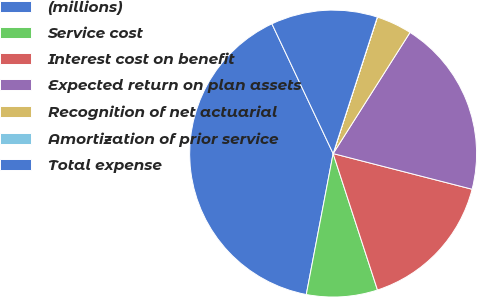<chart> <loc_0><loc_0><loc_500><loc_500><pie_chart><fcel>(millions)<fcel>Service cost<fcel>Interest cost on benefit<fcel>Expected return on plan assets<fcel>Recognition of net actuarial<fcel>Amortization of prior service<fcel>Total expense<nl><fcel>39.99%<fcel>8.0%<fcel>16.0%<fcel>20.0%<fcel>4.01%<fcel>0.01%<fcel>12.0%<nl></chart> 